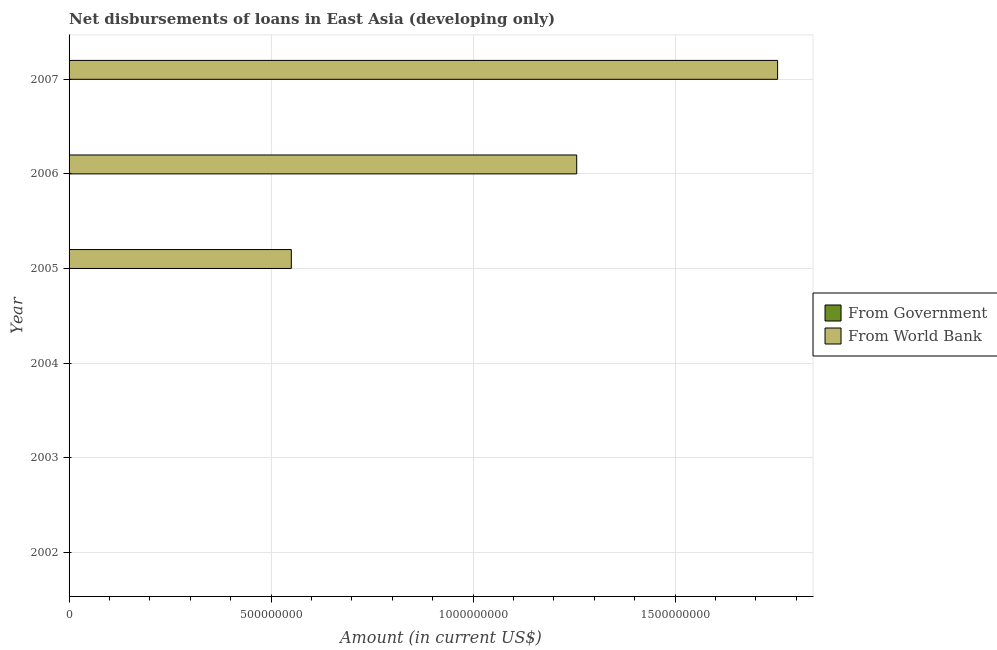How many different coloured bars are there?
Ensure brevity in your answer.  1. Are the number of bars on each tick of the Y-axis equal?
Your answer should be compact. No. How many bars are there on the 6th tick from the bottom?
Your answer should be very brief. 1. What is the net disbursements of loan from world bank in 2007?
Provide a succinct answer. 1.75e+09. Across all years, what is the maximum net disbursements of loan from world bank?
Your answer should be compact. 1.75e+09. Across all years, what is the minimum net disbursements of loan from government?
Provide a succinct answer. 0. In which year was the net disbursements of loan from world bank maximum?
Your answer should be compact. 2007. What is the total net disbursements of loan from world bank in the graph?
Make the answer very short. 3.56e+09. What is the difference between the net disbursements of loan from world bank in 2006 and that in 2007?
Your answer should be compact. -4.97e+08. What is the difference between the net disbursements of loan from government in 2005 and the net disbursements of loan from world bank in 2003?
Offer a very short reply. 0. What is the average net disbursements of loan from world bank per year?
Ensure brevity in your answer.  5.93e+08. In how many years, is the net disbursements of loan from government greater than 1700000000 US$?
Offer a very short reply. 0. What is the ratio of the net disbursements of loan from world bank in 2006 to that in 2007?
Your response must be concise. 0.72. What is the difference between the highest and the second highest net disbursements of loan from world bank?
Give a very brief answer. 4.97e+08. What is the difference between the highest and the lowest net disbursements of loan from world bank?
Your answer should be very brief. 1.75e+09. How many bars are there?
Make the answer very short. 3. Are all the bars in the graph horizontal?
Ensure brevity in your answer.  Yes. What is the title of the graph?
Ensure brevity in your answer.  Net disbursements of loans in East Asia (developing only). What is the Amount (in current US$) in From Government in 2002?
Provide a short and direct response. 0. What is the Amount (in current US$) in From World Bank in 2002?
Offer a very short reply. 0. What is the Amount (in current US$) of From World Bank in 2004?
Give a very brief answer. 0. What is the Amount (in current US$) in From World Bank in 2005?
Offer a very short reply. 5.50e+08. What is the Amount (in current US$) in From World Bank in 2006?
Provide a succinct answer. 1.26e+09. What is the Amount (in current US$) in From Government in 2007?
Offer a terse response. 0. What is the Amount (in current US$) of From World Bank in 2007?
Keep it short and to the point. 1.75e+09. Across all years, what is the maximum Amount (in current US$) of From World Bank?
Make the answer very short. 1.75e+09. What is the total Amount (in current US$) in From Government in the graph?
Keep it short and to the point. 0. What is the total Amount (in current US$) in From World Bank in the graph?
Offer a very short reply. 3.56e+09. What is the difference between the Amount (in current US$) in From World Bank in 2005 and that in 2006?
Provide a short and direct response. -7.06e+08. What is the difference between the Amount (in current US$) in From World Bank in 2005 and that in 2007?
Your response must be concise. -1.20e+09. What is the difference between the Amount (in current US$) of From World Bank in 2006 and that in 2007?
Offer a terse response. -4.97e+08. What is the average Amount (in current US$) of From Government per year?
Your answer should be compact. 0. What is the average Amount (in current US$) of From World Bank per year?
Your answer should be very brief. 5.93e+08. What is the ratio of the Amount (in current US$) of From World Bank in 2005 to that in 2006?
Give a very brief answer. 0.44. What is the ratio of the Amount (in current US$) in From World Bank in 2005 to that in 2007?
Provide a succinct answer. 0.31. What is the ratio of the Amount (in current US$) in From World Bank in 2006 to that in 2007?
Make the answer very short. 0.72. What is the difference between the highest and the second highest Amount (in current US$) of From World Bank?
Your response must be concise. 4.97e+08. What is the difference between the highest and the lowest Amount (in current US$) in From World Bank?
Your response must be concise. 1.75e+09. 